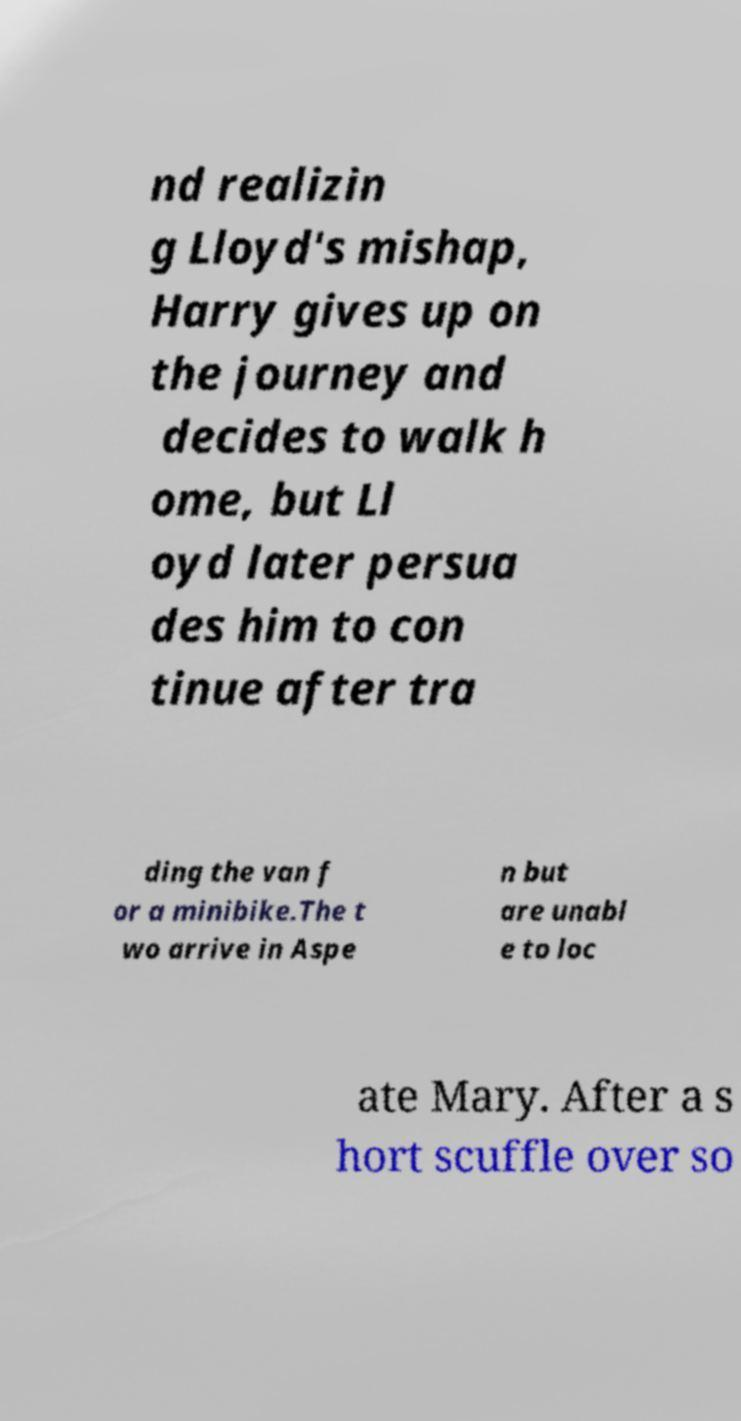Could you extract and type out the text from this image? nd realizin g Lloyd's mishap, Harry gives up on the journey and decides to walk h ome, but Ll oyd later persua des him to con tinue after tra ding the van f or a minibike.The t wo arrive in Aspe n but are unabl e to loc ate Mary. After a s hort scuffle over so 